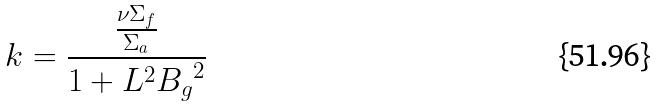<formula> <loc_0><loc_0><loc_500><loc_500>k = \frac { \frac { \nu \Sigma _ { f } } { \Sigma _ { a } } } { 1 + L ^ { 2 } { B _ { g } } ^ { 2 } }</formula> 